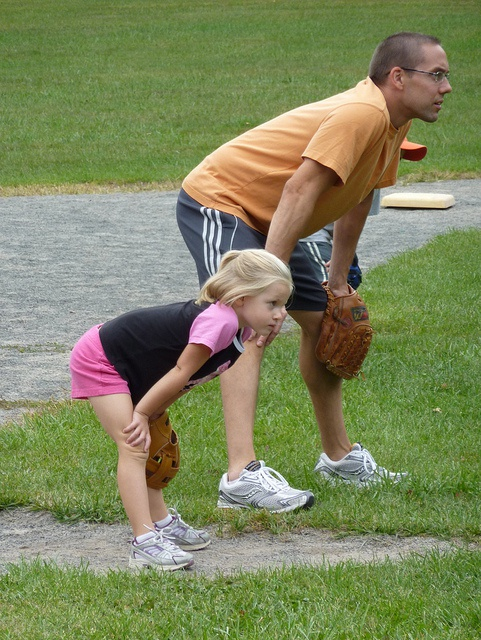Describe the objects in this image and their specific colors. I can see people in olive, maroon, and gray tones, people in olive, black, darkgray, tan, and gray tones, baseball glove in olive, maroon, black, and gray tones, and baseball glove in olive, maroon, and black tones in this image. 